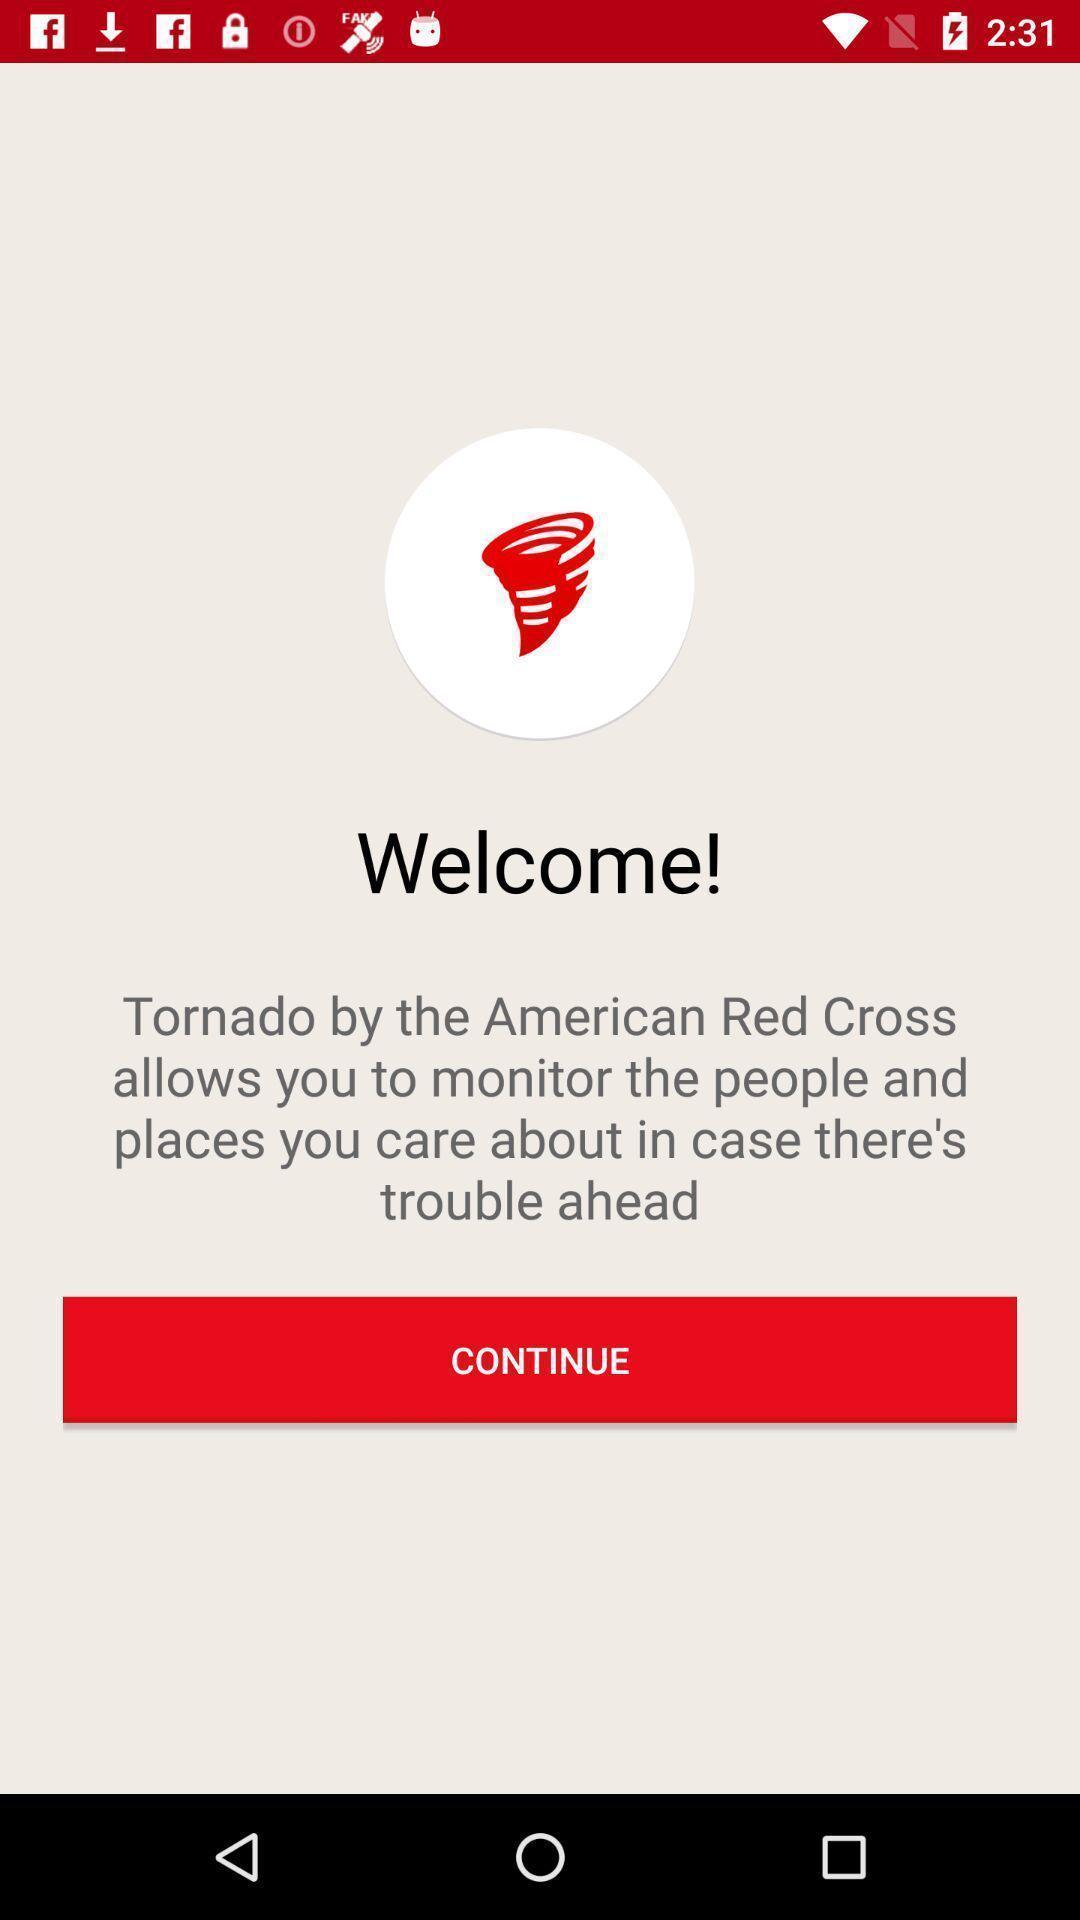Provide a detailed account of this screenshot. Welcoming page. 